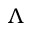<formula> <loc_0><loc_0><loc_500><loc_500>\Lambda</formula> 